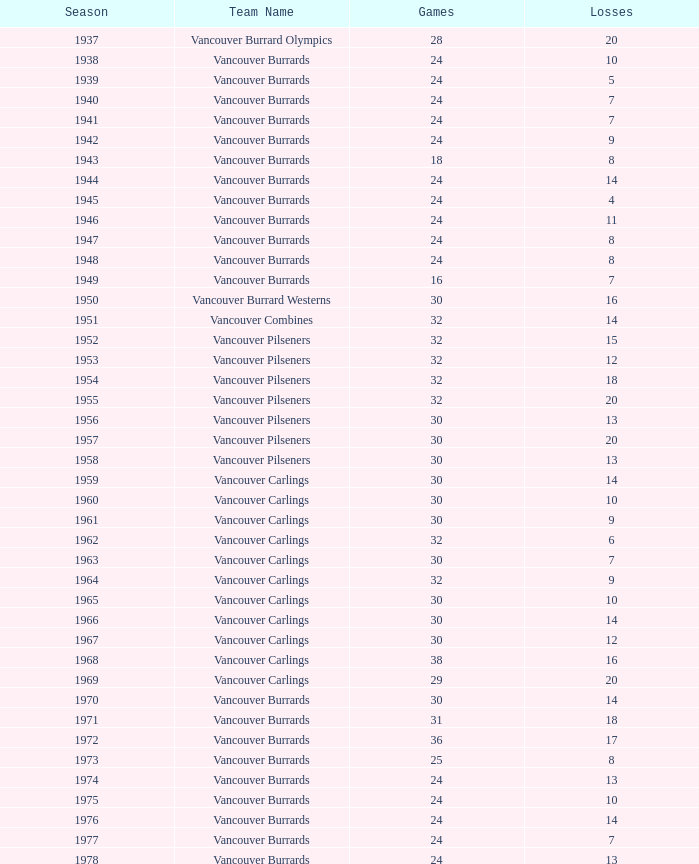What's the sum of points for the 1963 season when there are more than 30 games? None. 